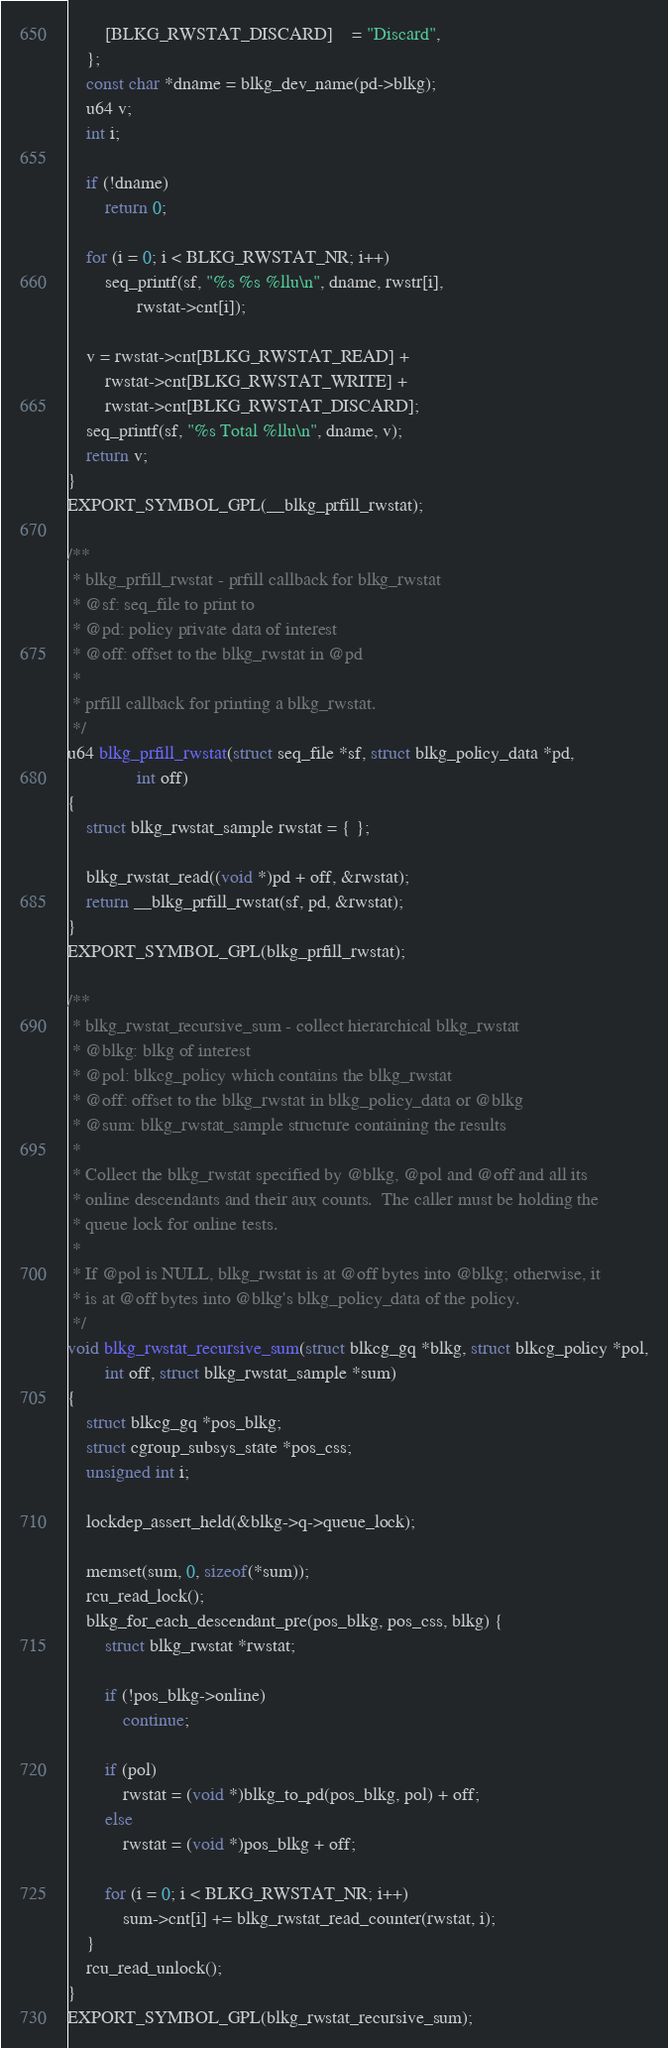Convert code to text. <code><loc_0><loc_0><loc_500><loc_500><_C_>		[BLKG_RWSTAT_DISCARD]	= "Discard",
	};
	const char *dname = blkg_dev_name(pd->blkg);
	u64 v;
	int i;

	if (!dname)
		return 0;

	for (i = 0; i < BLKG_RWSTAT_NR; i++)
		seq_printf(sf, "%s %s %llu\n", dname, rwstr[i],
			   rwstat->cnt[i]);

	v = rwstat->cnt[BLKG_RWSTAT_READ] +
		rwstat->cnt[BLKG_RWSTAT_WRITE] +
		rwstat->cnt[BLKG_RWSTAT_DISCARD];
	seq_printf(sf, "%s Total %llu\n", dname, v);
	return v;
}
EXPORT_SYMBOL_GPL(__blkg_prfill_rwstat);

/**
 * blkg_prfill_rwstat - prfill callback for blkg_rwstat
 * @sf: seq_file to print to
 * @pd: policy private data of interest
 * @off: offset to the blkg_rwstat in @pd
 *
 * prfill callback for printing a blkg_rwstat.
 */
u64 blkg_prfill_rwstat(struct seq_file *sf, struct blkg_policy_data *pd,
		       int off)
{
	struct blkg_rwstat_sample rwstat = { };

	blkg_rwstat_read((void *)pd + off, &rwstat);
	return __blkg_prfill_rwstat(sf, pd, &rwstat);
}
EXPORT_SYMBOL_GPL(blkg_prfill_rwstat);

/**
 * blkg_rwstat_recursive_sum - collect hierarchical blkg_rwstat
 * @blkg: blkg of interest
 * @pol: blkcg_policy which contains the blkg_rwstat
 * @off: offset to the blkg_rwstat in blkg_policy_data or @blkg
 * @sum: blkg_rwstat_sample structure containing the results
 *
 * Collect the blkg_rwstat specified by @blkg, @pol and @off and all its
 * online descendants and their aux counts.  The caller must be holding the
 * queue lock for online tests.
 *
 * If @pol is NULL, blkg_rwstat is at @off bytes into @blkg; otherwise, it
 * is at @off bytes into @blkg's blkg_policy_data of the policy.
 */
void blkg_rwstat_recursive_sum(struct blkcg_gq *blkg, struct blkcg_policy *pol,
		int off, struct blkg_rwstat_sample *sum)
{
	struct blkcg_gq *pos_blkg;
	struct cgroup_subsys_state *pos_css;
	unsigned int i;

	lockdep_assert_held(&blkg->q->queue_lock);

	memset(sum, 0, sizeof(*sum));
	rcu_read_lock();
	blkg_for_each_descendant_pre(pos_blkg, pos_css, blkg) {
		struct blkg_rwstat *rwstat;

		if (!pos_blkg->online)
			continue;

		if (pol)
			rwstat = (void *)blkg_to_pd(pos_blkg, pol) + off;
		else
			rwstat = (void *)pos_blkg + off;

		for (i = 0; i < BLKG_RWSTAT_NR; i++)
			sum->cnt[i] += blkg_rwstat_read_counter(rwstat, i);
	}
	rcu_read_unlock();
}
EXPORT_SYMBOL_GPL(blkg_rwstat_recursive_sum);
</code> 